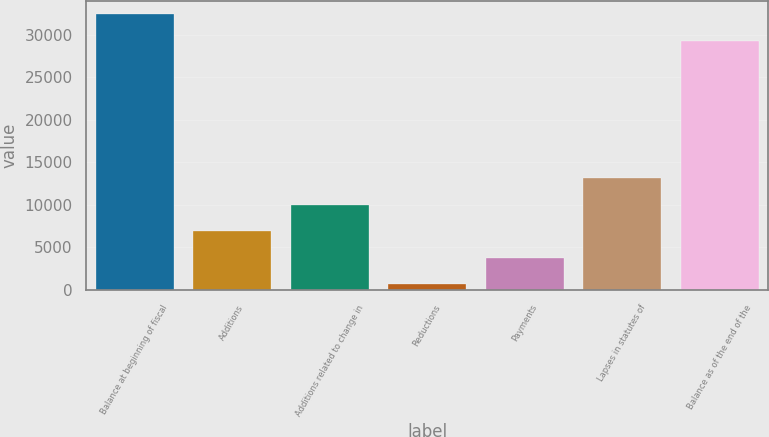Convert chart. <chart><loc_0><loc_0><loc_500><loc_500><bar_chart><fcel>Balance at beginning of fiscal<fcel>Additions<fcel>Additions related to change in<fcel>Reductions<fcel>Payments<fcel>Lapses in statutes of<fcel>Balance as of the end of the<nl><fcel>32368<fcel>6918<fcel>10027<fcel>700<fcel>3809<fcel>13136<fcel>29259<nl></chart> 